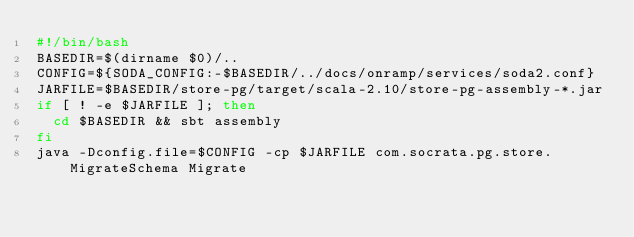Convert code to text. <code><loc_0><loc_0><loc_500><loc_500><_Bash_>#!/bin/bash
BASEDIR=$(dirname $0)/..
CONFIG=${SODA_CONFIG:-$BASEDIR/../docs/onramp/services/soda2.conf}
JARFILE=$BASEDIR/store-pg/target/scala-2.10/store-pg-assembly-*.jar
if [ ! -e $JARFILE ]; then
  cd $BASEDIR && sbt assembly
fi
java -Dconfig.file=$CONFIG -cp $JARFILE com.socrata.pg.store.MigrateSchema Migrate</code> 